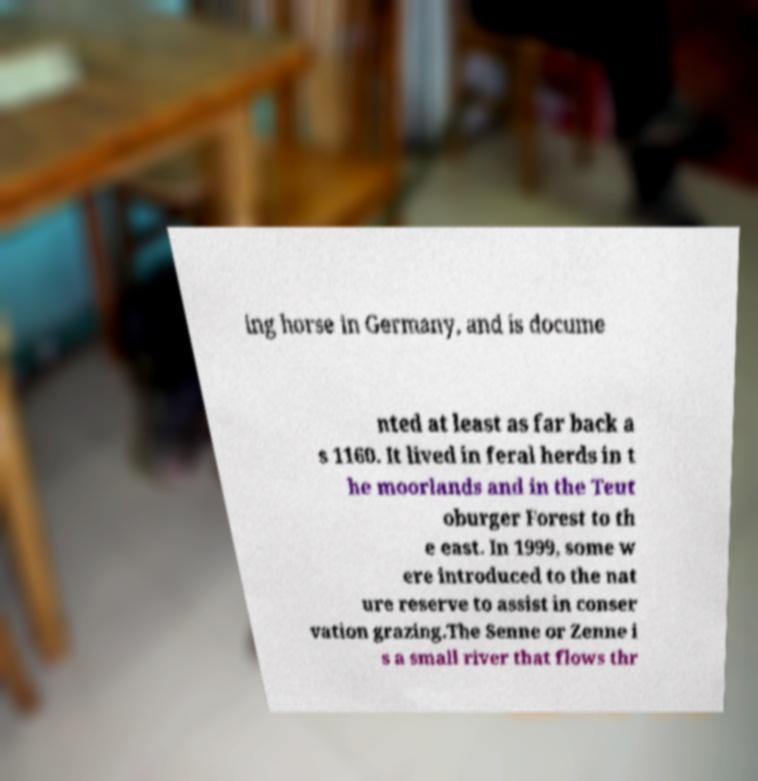Could you assist in decoding the text presented in this image and type it out clearly? ing horse in Germany, and is docume nted at least as far back a s 1160. It lived in feral herds in t he moorlands and in the Teut oburger Forest to th e east. In 1999, some w ere introduced to the nat ure reserve to assist in conser vation grazing.The Senne or Zenne i s a small river that flows thr 